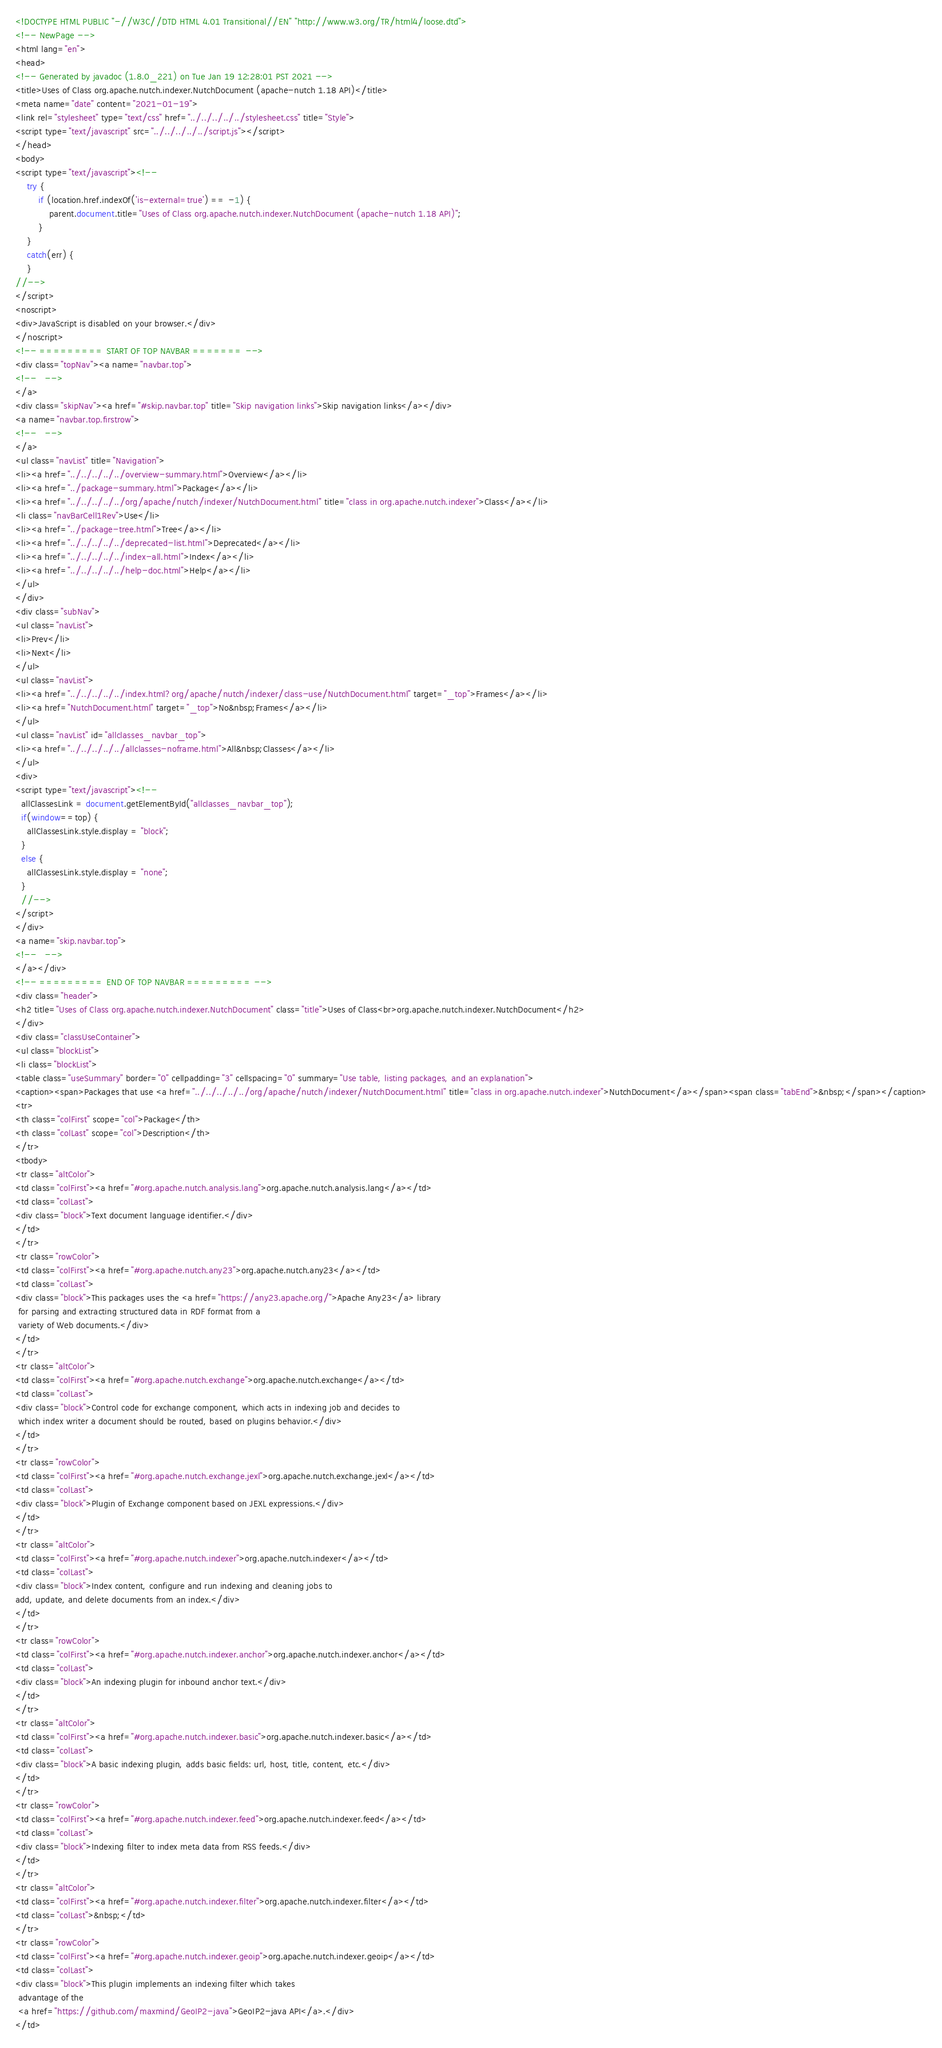Convert code to text. <code><loc_0><loc_0><loc_500><loc_500><_HTML_><!DOCTYPE HTML PUBLIC "-//W3C//DTD HTML 4.01 Transitional//EN" "http://www.w3.org/TR/html4/loose.dtd">
<!-- NewPage -->
<html lang="en">
<head>
<!-- Generated by javadoc (1.8.0_221) on Tue Jan 19 12:28:01 PST 2021 -->
<title>Uses of Class org.apache.nutch.indexer.NutchDocument (apache-nutch 1.18 API)</title>
<meta name="date" content="2021-01-19">
<link rel="stylesheet" type="text/css" href="../../../../../stylesheet.css" title="Style">
<script type="text/javascript" src="../../../../../script.js"></script>
</head>
<body>
<script type="text/javascript"><!--
    try {
        if (location.href.indexOf('is-external=true') == -1) {
            parent.document.title="Uses of Class org.apache.nutch.indexer.NutchDocument (apache-nutch 1.18 API)";
        }
    }
    catch(err) {
    }
//-->
</script>
<noscript>
<div>JavaScript is disabled on your browser.</div>
</noscript>
<!-- ========= START OF TOP NAVBAR ======= -->
<div class="topNav"><a name="navbar.top">
<!--   -->
</a>
<div class="skipNav"><a href="#skip.navbar.top" title="Skip navigation links">Skip navigation links</a></div>
<a name="navbar.top.firstrow">
<!--   -->
</a>
<ul class="navList" title="Navigation">
<li><a href="../../../../../overview-summary.html">Overview</a></li>
<li><a href="../package-summary.html">Package</a></li>
<li><a href="../../../../../org/apache/nutch/indexer/NutchDocument.html" title="class in org.apache.nutch.indexer">Class</a></li>
<li class="navBarCell1Rev">Use</li>
<li><a href="../package-tree.html">Tree</a></li>
<li><a href="../../../../../deprecated-list.html">Deprecated</a></li>
<li><a href="../../../../../index-all.html">Index</a></li>
<li><a href="../../../../../help-doc.html">Help</a></li>
</ul>
</div>
<div class="subNav">
<ul class="navList">
<li>Prev</li>
<li>Next</li>
</ul>
<ul class="navList">
<li><a href="../../../../../index.html?org/apache/nutch/indexer/class-use/NutchDocument.html" target="_top">Frames</a></li>
<li><a href="NutchDocument.html" target="_top">No&nbsp;Frames</a></li>
</ul>
<ul class="navList" id="allclasses_navbar_top">
<li><a href="../../../../../allclasses-noframe.html">All&nbsp;Classes</a></li>
</ul>
<div>
<script type="text/javascript"><!--
  allClassesLink = document.getElementById("allclasses_navbar_top");
  if(window==top) {
    allClassesLink.style.display = "block";
  }
  else {
    allClassesLink.style.display = "none";
  }
  //-->
</script>
</div>
<a name="skip.navbar.top">
<!--   -->
</a></div>
<!-- ========= END OF TOP NAVBAR ========= -->
<div class="header">
<h2 title="Uses of Class org.apache.nutch.indexer.NutchDocument" class="title">Uses of Class<br>org.apache.nutch.indexer.NutchDocument</h2>
</div>
<div class="classUseContainer">
<ul class="blockList">
<li class="blockList">
<table class="useSummary" border="0" cellpadding="3" cellspacing="0" summary="Use table, listing packages, and an explanation">
<caption><span>Packages that use <a href="../../../../../org/apache/nutch/indexer/NutchDocument.html" title="class in org.apache.nutch.indexer">NutchDocument</a></span><span class="tabEnd">&nbsp;</span></caption>
<tr>
<th class="colFirst" scope="col">Package</th>
<th class="colLast" scope="col">Description</th>
</tr>
<tbody>
<tr class="altColor">
<td class="colFirst"><a href="#org.apache.nutch.analysis.lang">org.apache.nutch.analysis.lang</a></td>
<td class="colLast">
<div class="block">Text document language identifier.</div>
</td>
</tr>
<tr class="rowColor">
<td class="colFirst"><a href="#org.apache.nutch.any23">org.apache.nutch.any23</a></td>
<td class="colLast">
<div class="block">This packages uses the <a href="https://any23.apache.org/">Apache Any23</a> library
 for parsing and extracting structured data in RDF format from a
 variety of Web documents.</div>
</td>
</tr>
<tr class="altColor">
<td class="colFirst"><a href="#org.apache.nutch.exchange">org.apache.nutch.exchange</a></td>
<td class="colLast">
<div class="block">Control code for exchange component, which acts in indexing job and decides to
 which index writer a document should be routed, based on plugins behavior.</div>
</td>
</tr>
<tr class="rowColor">
<td class="colFirst"><a href="#org.apache.nutch.exchange.jexl">org.apache.nutch.exchange.jexl</a></td>
<td class="colLast">
<div class="block">Plugin of Exchange component based on JEXL expressions.</div>
</td>
</tr>
<tr class="altColor">
<td class="colFirst"><a href="#org.apache.nutch.indexer">org.apache.nutch.indexer</a></td>
<td class="colLast">
<div class="block">Index content, configure and run indexing and cleaning jobs to 
add, update, and delete documents from an index.</div>
</td>
</tr>
<tr class="rowColor">
<td class="colFirst"><a href="#org.apache.nutch.indexer.anchor">org.apache.nutch.indexer.anchor</a></td>
<td class="colLast">
<div class="block">An indexing plugin for inbound anchor text.</div>
</td>
</tr>
<tr class="altColor">
<td class="colFirst"><a href="#org.apache.nutch.indexer.basic">org.apache.nutch.indexer.basic</a></td>
<td class="colLast">
<div class="block">A basic indexing plugin, adds basic fields: url, host, title, content, etc.</div>
</td>
</tr>
<tr class="rowColor">
<td class="colFirst"><a href="#org.apache.nutch.indexer.feed">org.apache.nutch.indexer.feed</a></td>
<td class="colLast">
<div class="block">Indexing filter to index meta data from RSS feeds.</div>
</td>
</tr>
<tr class="altColor">
<td class="colFirst"><a href="#org.apache.nutch.indexer.filter">org.apache.nutch.indexer.filter</a></td>
<td class="colLast">&nbsp;</td>
</tr>
<tr class="rowColor">
<td class="colFirst"><a href="#org.apache.nutch.indexer.geoip">org.apache.nutch.indexer.geoip</a></td>
<td class="colLast">
<div class="block">This plugin implements an indexing filter which takes 
 advantage of the 
 <a href="https://github.com/maxmind/GeoIP2-java">GeoIP2-java API</a>.</div>
</td></code> 